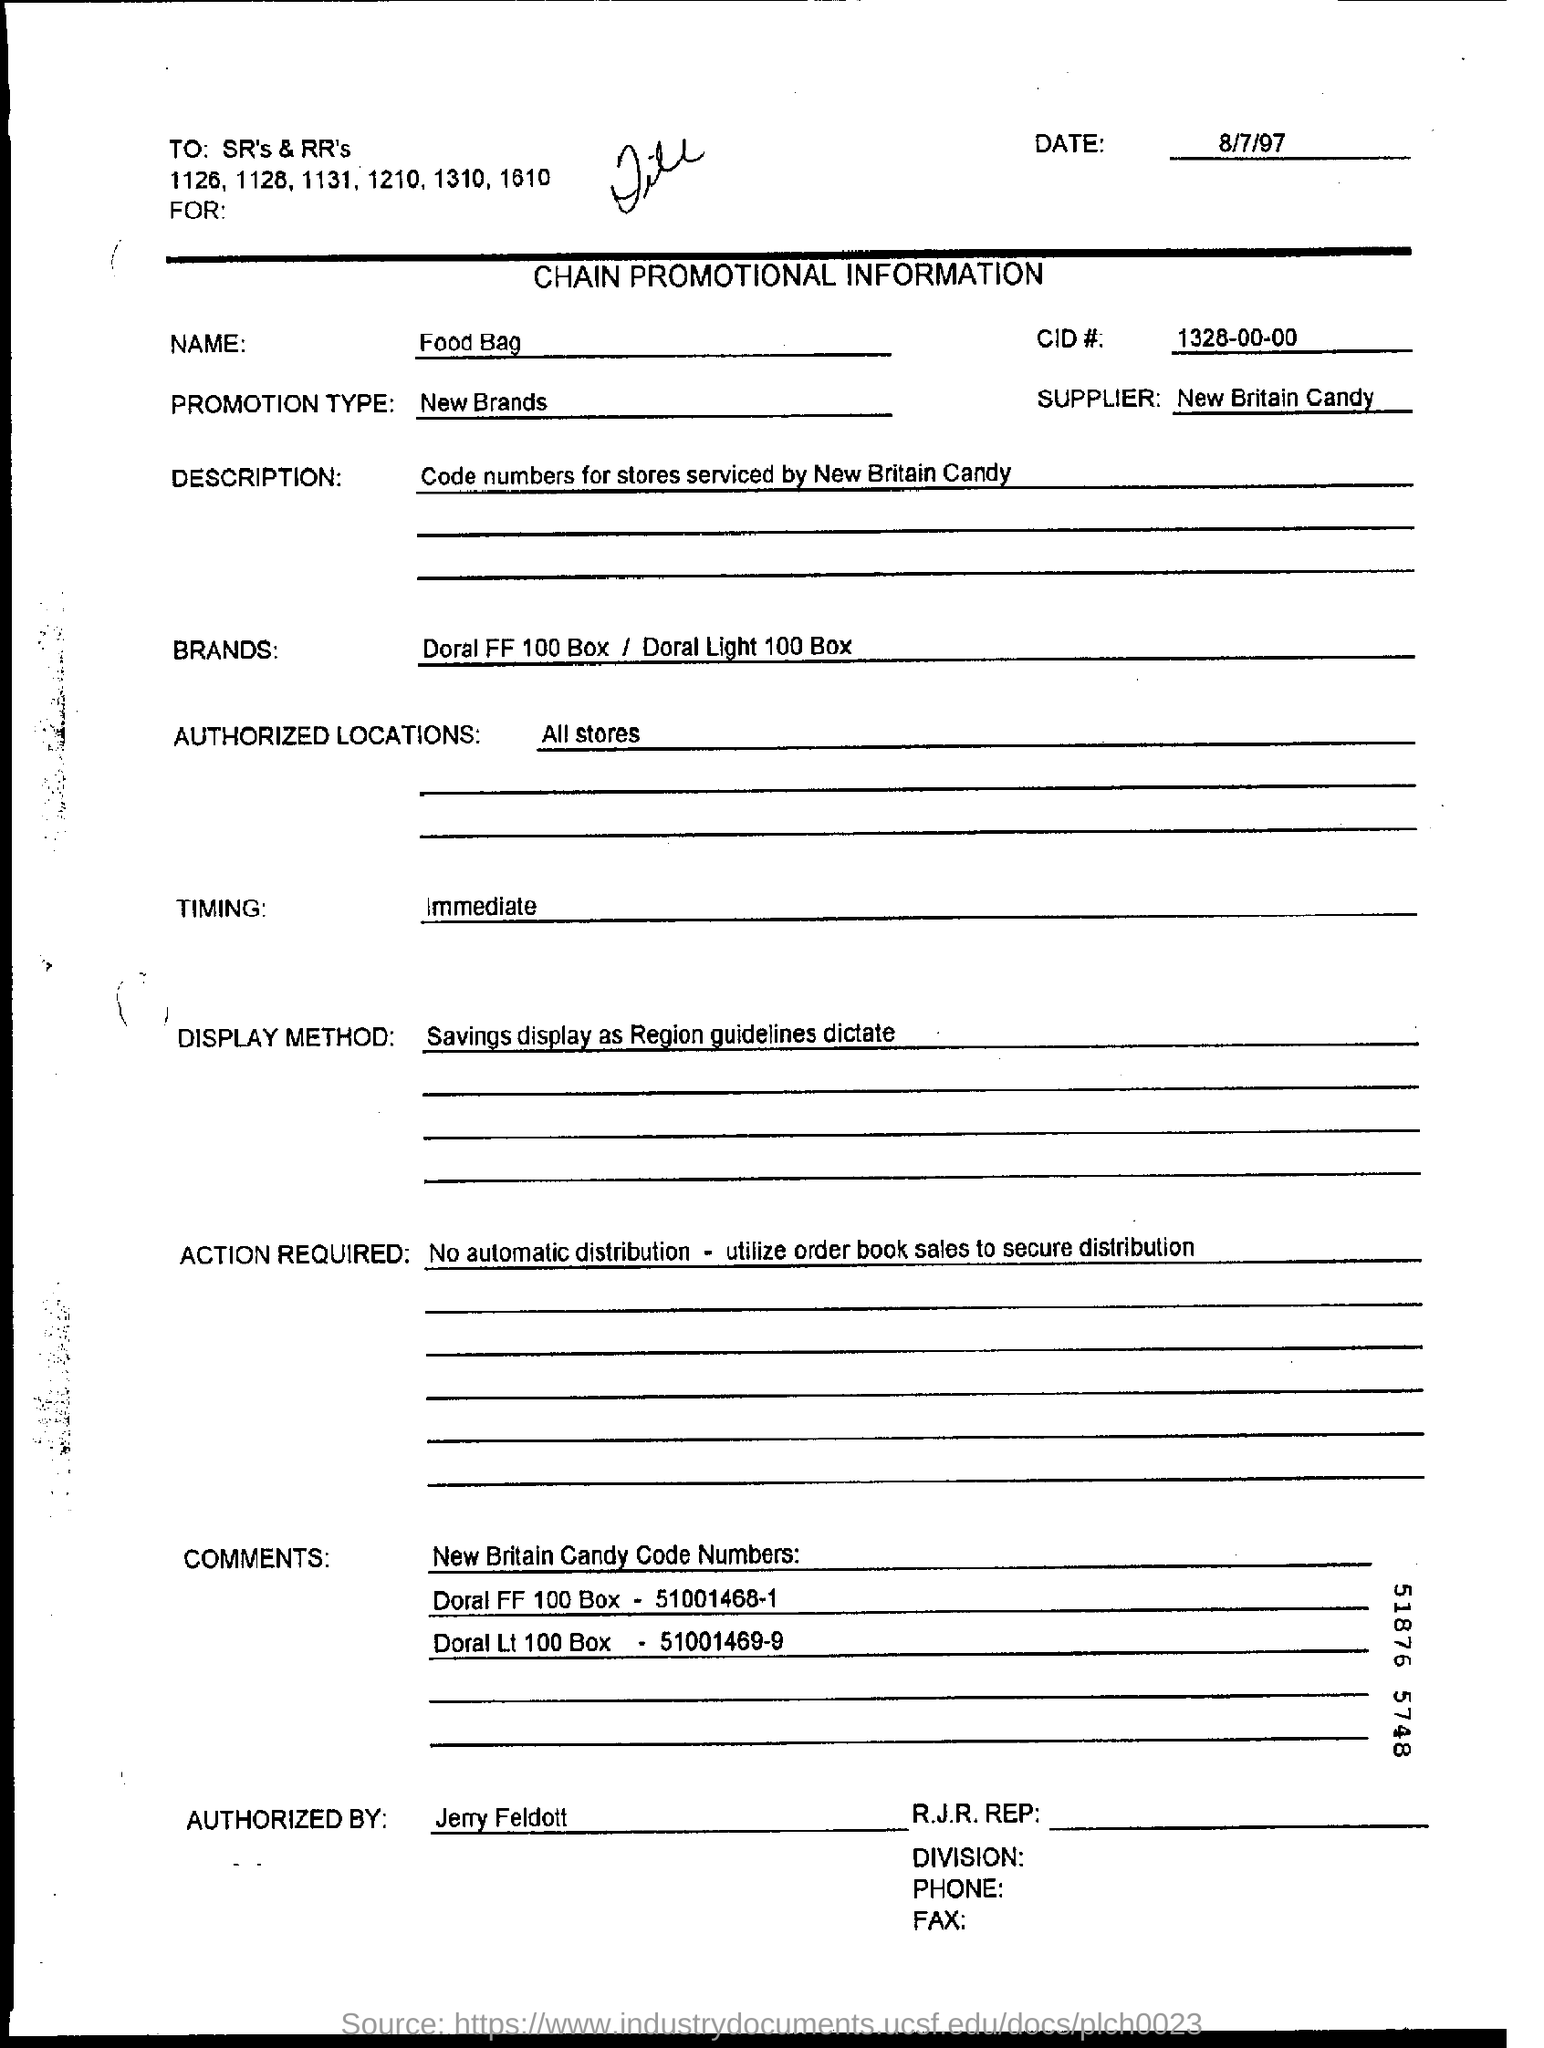What is the Promotion type given?
Your response must be concise. New Brands. What is the CID# mentioned in the document?
Provide a short and direct response. 1328-00-00. Who is the supplier mentioned here?
Your answer should be compact. New Britain Candy. Which Brand's Chain Promotional Information is given?
Keep it short and to the point. Doral FF 100 Box / Doral Light 100 Box. Which are the authorized locations mentioned in the document?
Ensure brevity in your answer.  All stores. What is the display method as per the document?
Your answer should be compact. Savings display as Region guidelines dictate. 